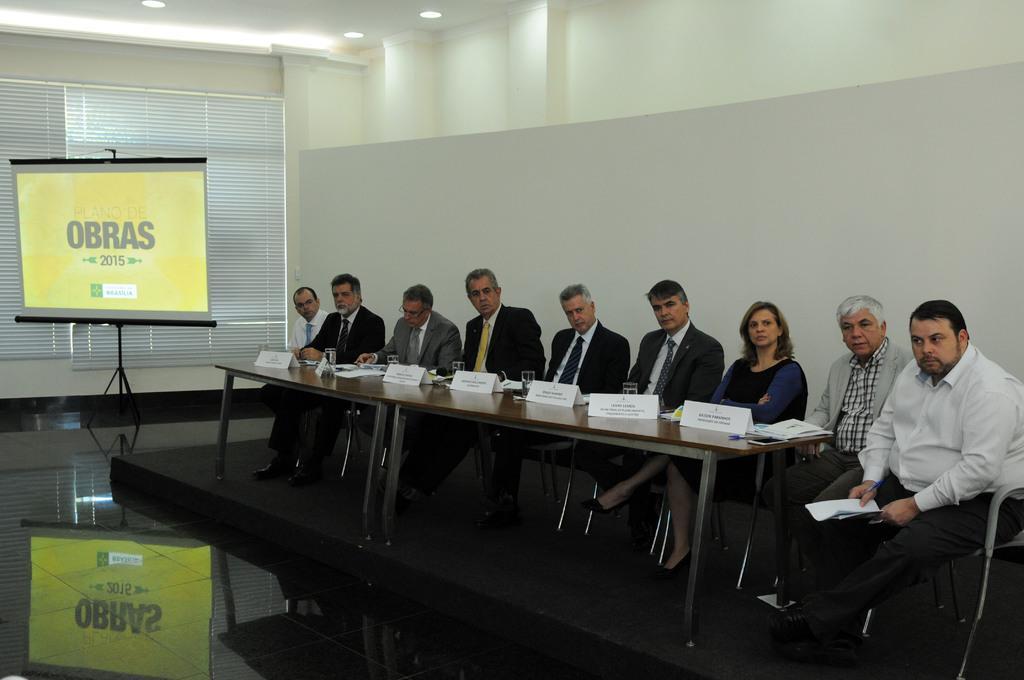Please provide a concise description of this image. In this image, we can see persons wearing clothes and sitting on chairs in front of the table. This table contains glasses and boards. There is a screen in front of window blinds. There are lights on the ceiling which is in the top left of the image. 